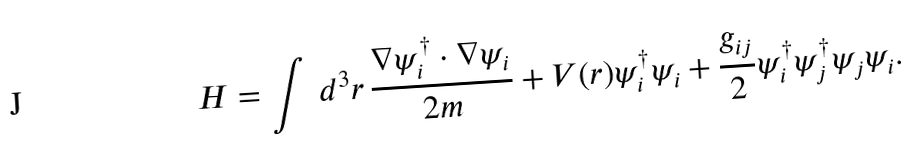Convert formula to latex. <formula><loc_0><loc_0><loc_500><loc_500>H = \int \, d ^ { 3 } r \, \frac { \nabla \psi _ { i } ^ { \dagger } \cdot \nabla \psi _ { i } } { 2 m } + V ( r ) \psi _ { i } ^ { \dagger } \psi _ { i } + \frac { g _ { i j } } { 2 } \psi ^ { \dagger } _ { i } \psi ^ { \dagger } _ { j } \psi _ { j } \psi _ { i } .</formula> 